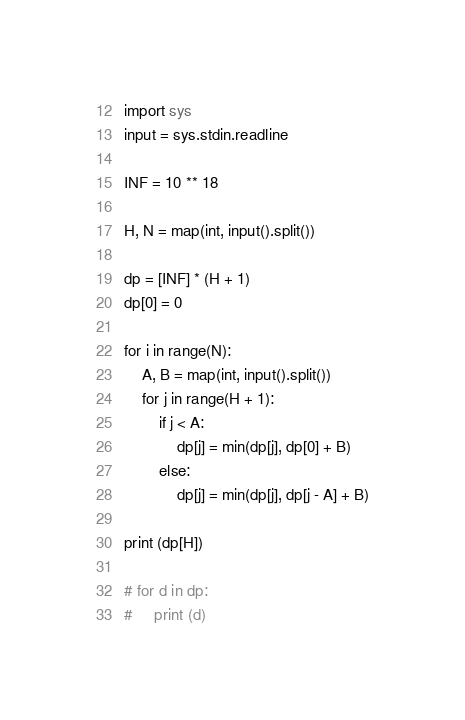<code> <loc_0><loc_0><loc_500><loc_500><_Python_>import sys
input = sys.stdin.readline

INF = 10 ** 18

H, N = map(int, input().split())

dp = [INF] * (H + 1)
dp[0] = 0

for i in range(N):
    A, B = map(int, input().split())
    for j in range(H + 1):
        if j < A:
            dp[j] = min(dp[j], dp[0] + B)
        else:
            dp[j] = min(dp[j], dp[j - A] + B)
    
print (dp[H])

# for d in dp:
#     print (d)</code> 